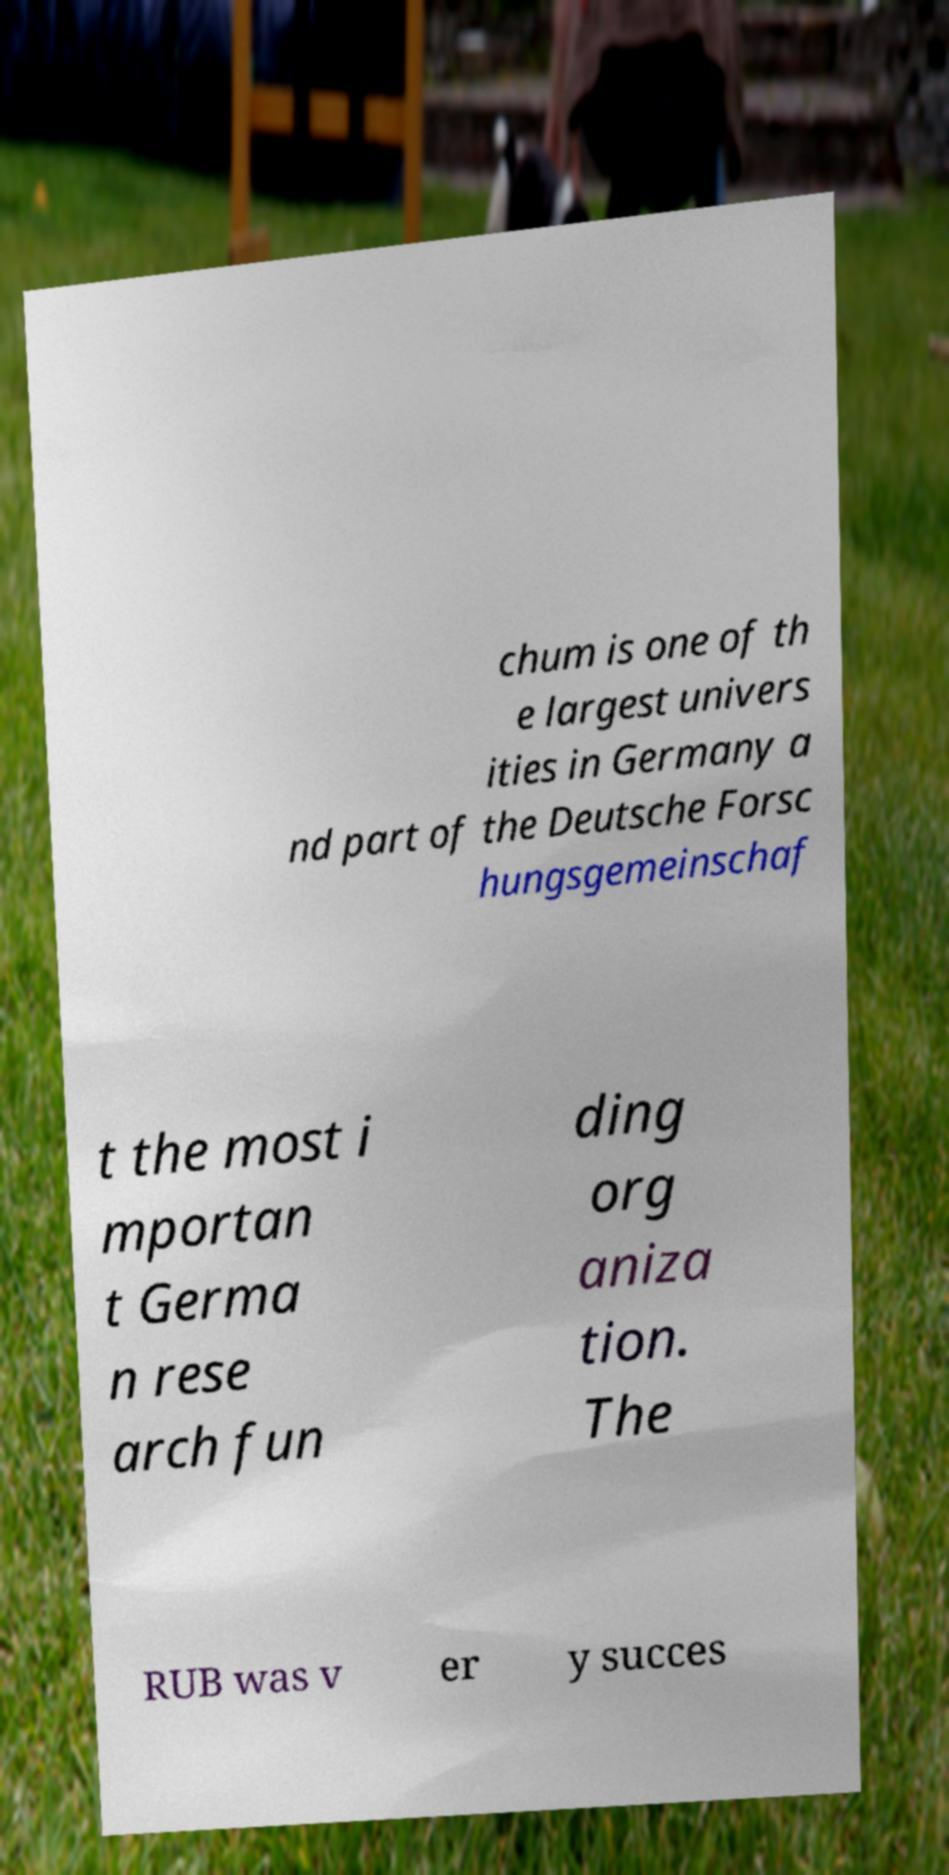I need the written content from this picture converted into text. Can you do that? chum is one of th e largest univers ities in Germany a nd part of the Deutsche Forsc hungsgemeinschaf t the most i mportan t Germa n rese arch fun ding org aniza tion. The RUB was v er y succes 